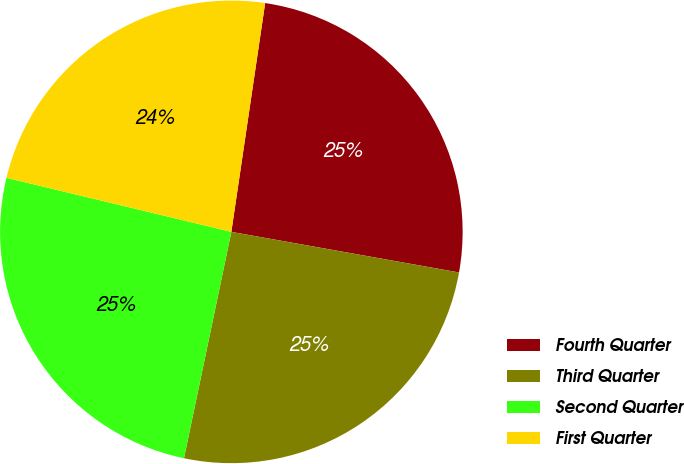<chart> <loc_0><loc_0><loc_500><loc_500><pie_chart><fcel>Fourth Quarter<fcel>Third Quarter<fcel>Second Quarter<fcel>First Quarter<nl><fcel>25.47%<fcel>25.47%<fcel>25.47%<fcel>23.58%<nl></chart> 